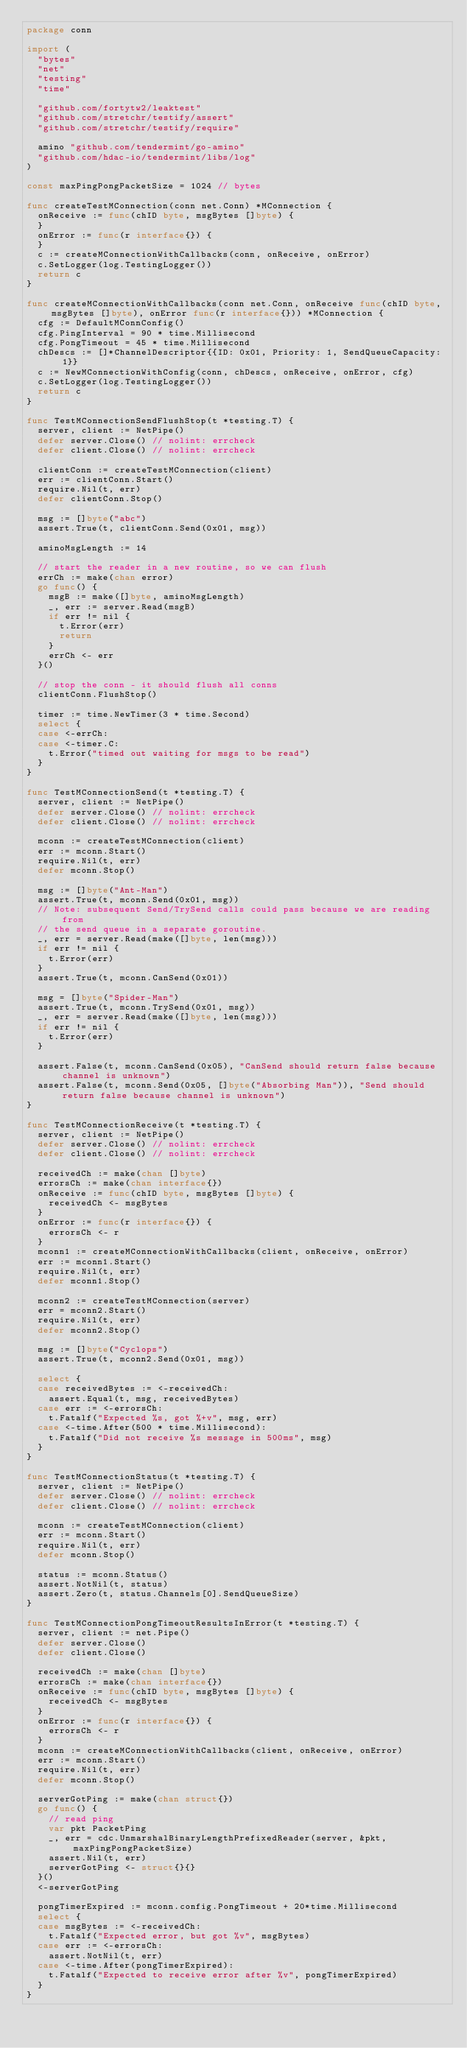Convert code to text. <code><loc_0><loc_0><loc_500><loc_500><_Go_>package conn

import (
	"bytes"
	"net"
	"testing"
	"time"

	"github.com/fortytw2/leaktest"
	"github.com/stretchr/testify/assert"
	"github.com/stretchr/testify/require"

	amino "github.com/tendermint/go-amino"
	"github.com/hdac-io/tendermint/libs/log"
)

const maxPingPongPacketSize = 1024 // bytes

func createTestMConnection(conn net.Conn) *MConnection {
	onReceive := func(chID byte, msgBytes []byte) {
	}
	onError := func(r interface{}) {
	}
	c := createMConnectionWithCallbacks(conn, onReceive, onError)
	c.SetLogger(log.TestingLogger())
	return c
}

func createMConnectionWithCallbacks(conn net.Conn, onReceive func(chID byte, msgBytes []byte), onError func(r interface{})) *MConnection {
	cfg := DefaultMConnConfig()
	cfg.PingInterval = 90 * time.Millisecond
	cfg.PongTimeout = 45 * time.Millisecond
	chDescs := []*ChannelDescriptor{{ID: 0x01, Priority: 1, SendQueueCapacity: 1}}
	c := NewMConnectionWithConfig(conn, chDescs, onReceive, onError, cfg)
	c.SetLogger(log.TestingLogger())
	return c
}

func TestMConnectionSendFlushStop(t *testing.T) {
	server, client := NetPipe()
	defer server.Close() // nolint: errcheck
	defer client.Close() // nolint: errcheck

	clientConn := createTestMConnection(client)
	err := clientConn.Start()
	require.Nil(t, err)
	defer clientConn.Stop()

	msg := []byte("abc")
	assert.True(t, clientConn.Send(0x01, msg))

	aminoMsgLength := 14

	// start the reader in a new routine, so we can flush
	errCh := make(chan error)
	go func() {
		msgB := make([]byte, aminoMsgLength)
		_, err := server.Read(msgB)
		if err != nil {
			t.Error(err)
			return
		}
		errCh <- err
	}()

	// stop the conn - it should flush all conns
	clientConn.FlushStop()

	timer := time.NewTimer(3 * time.Second)
	select {
	case <-errCh:
	case <-timer.C:
		t.Error("timed out waiting for msgs to be read")
	}
}

func TestMConnectionSend(t *testing.T) {
	server, client := NetPipe()
	defer server.Close() // nolint: errcheck
	defer client.Close() // nolint: errcheck

	mconn := createTestMConnection(client)
	err := mconn.Start()
	require.Nil(t, err)
	defer mconn.Stop()

	msg := []byte("Ant-Man")
	assert.True(t, mconn.Send(0x01, msg))
	// Note: subsequent Send/TrySend calls could pass because we are reading from
	// the send queue in a separate goroutine.
	_, err = server.Read(make([]byte, len(msg)))
	if err != nil {
		t.Error(err)
	}
	assert.True(t, mconn.CanSend(0x01))

	msg = []byte("Spider-Man")
	assert.True(t, mconn.TrySend(0x01, msg))
	_, err = server.Read(make([]byte, len(msg)))
	if err != nil {
		t.Error(err)
	}

	assert.False(t, mconn.CanSend(0x05), "CanSend should return false because channel is unknown")
	assert.False(t, mconn.Send(0x05, []byte("Absorbing Man")), "Send should return false because channel is unknown")
}

func TestMConnectionReceive(t *testing.T) {
	server, client := NetPipe()
	defer server.Close() // nolint: errcheck
	defer client.Close() // nolint: errcheck

	receivedCh := make(chan []byte)
	errorsCh := make(chan interface{})
	onReceive := func(chID byte, msgBytes []byte) {
		receivedCh <- msgBytes
	}
	onError := func(r interface{}) {
		errorsCh <- r
	}
	mconn1 := createMConnectionWithCallbacks(client, onReceive, onError)
	err := mconn1.Start()
	require.Nil(t, err)
	defer mconn1.Stop()

	mconn2 := createTestMConnection(server)
	err = mconn2.Start()
	require.Nil(t, err)
	defer mconn2.Stop()

	msg := []byte("Cyclops")
	assert.True(t, mconn2.Send(0x01, msg))

	select {
	case receivedBytes := <-receivedCh:
		assert.Equal(t, msg, receivedBytes)
	case err := <-errorsCh:
		t.Fatalf("Expected %s, got %+v", msg, err)
	case <-time.After(500 * time.Millisecond):
		t.Fatalf("Did not receive %s message in 500ms", msg)
	}
}

func TestMConnectionStatus(t *testing.T) {
	server, client := NetPipe()
	defer server.Close() // nolint: errcheck
	defer client.Close() // nolint: errcheck

	mconn := createTestMConnection(client)
	err := mconn.Start()
	require.Nil(t, err)
	defer mconn.Stop()

	status := mconn.Status()
	assert.NotNil(t, status)
	assert.Zero(t, status.Channels[0].SendQueueSize)
}

func TestMConnectionPongTimeoutResultsInError(t *testing.T) {
	server, client := net.Pipe()
	defer server.Close()
	defer client.Close()

	receivedCh := make(chan []byte)
	errorsCh := make(chan interface{})
	onReceive := func(chID byte, msgBytes []byte) {
		receivedCh <- msgBytes
	}
	onError := func(r interface{}) {
		errorsCh <- r
	}
	mconn := createMConnectionWithCallbacks(client, onReceive, onError)
	err := mconn.Start()
	require.Nil(t, err)
	defer mconn.Stop()

	serverGotPing := make(chan struct{})
	go func() {
		// read ping
		var pkt PacketPing
		_, err = cdc.UnmarshalBinaryLengthPrefixedReader(server, &pkt, maxPingPongPacketSize)
		assert.Nil(t, err)
		serverGotPing <- struct{}{}
	}()
	<-serverGotPing

	pongTimerExpired := mconn.config.PongTimeout + 20*time.Millisecond
	select {
	case msgBytes := <-receivedCh:
		t.Fatalf("Expected error, but got %v", msgBytes)
	case err := <-errorsCh:
		assert.NotNil(t, err)
	case <-time.After(pongTimerExpired):
		t.Fatalf("Expected to receive error after %v", pongTimerExpired)
	}
}
</code> 